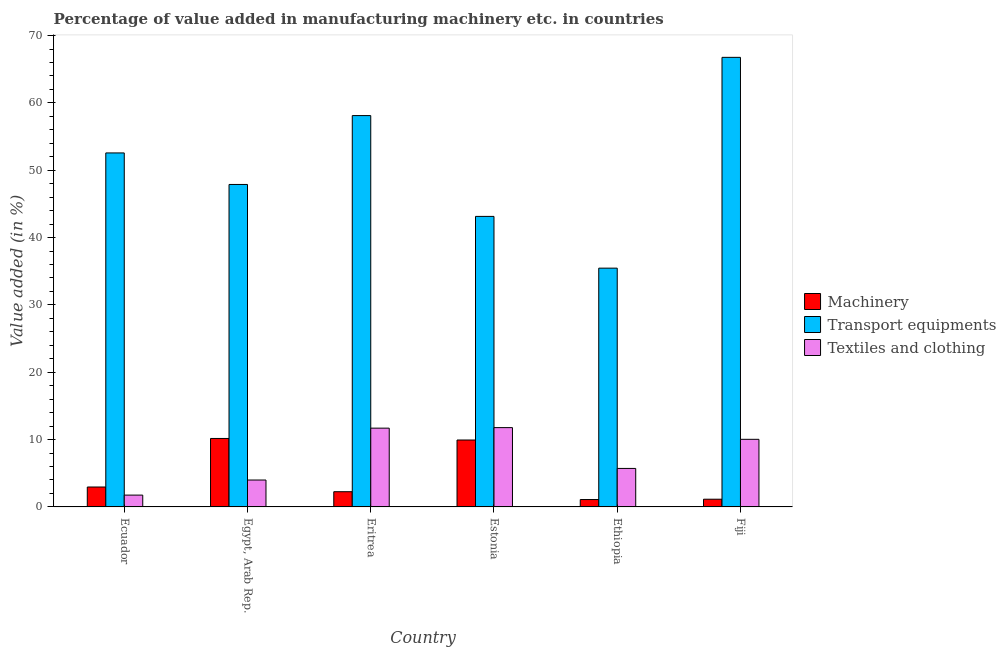How many different coloured bars are there?
Provide a succinct answer. 3. Are the number of bars on each tick of the X-axis equal?
Offer a very short reply. Yes. How many bars are there on the 5th tick from the left?
Provide a short and direct response. 3. How many bars are there on the 2nd tick from the right?
Offer a terse response. 3. What is the label of the 2nd group of bars from the left?
Your answer should be very brief. Egypt, Arab Rep. What is the value added in manufacturing transport equipments in Ethiopia?
Provide a succinct answer. 35.46. Across all countries, what is the maximum value added in manufacturing machinery?
Give a very brief answer. 10.17. Across all countries, what is the minimum value added in manufacturing textile and clothing?
Make the answer very short. 1.76. In which country was the value added in manufacturing machinery maximum?
Offer a very short reply. Egypt, Arab Rep. In which country was the value added in manufacturing machinery minimum?
Offer a very short reply. Ethiopia. What is the total value added in manufacturing machinery in the graph?
Give a very brief answer. 27.57. What is the difference between the value added in manufacturing transport equipments in Estonia and that in Fiji?
Offer a terse response. -23.62. What is the difference between the value added in manufacturing transport equipments in Fiji and the value added in manufacturing textile and clothing in Egypt, Arab Rep.?
Give a very brief answer. 62.77. What is the average value added in manufacturing transport equipments per country?
Offer a terse response. 50.66. What is the difference between the value added in manufacturing transport equipments and value added in manufacturing textile and clothing in Egypt, Arab Rep.?
Your response must be concise. 43.89. What is the ratio of the value added in manufacturing textile and clothing in Ecuador to that in Eritrea?
Offer a terse response. 0.15. What is the difference between the highest and the second highest value added in manufacturing machinery?
Offer a very short reply. 0.23. What is the difference between the highest and the lowest value added in manufacturing machinery?
Provide a succinct answer. 9.07. In how many countries, is the value added in manufacturing transport equipments greater than the average value added in manufacturing transport equipments taken over all countries?
Provide a succinct answer. 3. What does the 2nd bar from the left in Egypt, Arab Rep. represents?
Your response must be concise. Transport equipments. What does the 3rd bar from the right in Estonia represents?
Offer a terse response. Machinery. Is it the case that in every country, the sum of the value added in manufacturing machinery and value added in manufacturing transport equipments is greater than the value added in manufacturing textile and clothing?
Your response must be concise. Yes. Are all the bars in the graph horizontal?
Provide a short and direct response. No. What is the difference between two consecutive major ticks on the Y-axis?
Keep it short and to the point. 10. Are the values on the major ticks of Y-axis written in scientific E-notation?
Give a very brief answer. No. Does the graph contain any zero values?
Keep it short and to the point. No. How many legend labels are there?
Your answer should be very brief. 3. What is the title of the graph?
Provide a short and direct response. Percentage of value added in manufacturing machinery etc. in countries. What is the label or title of the Y-axis?
Ensure brevity in your answer.  Value added (in %). What is the Value added (in %) in Machinery in Ecuador?
Make the answer very short. 2.96. What is the Value added (in %) in Transport equipments in Ecuador?
Keep it short and to the point. 52.57. What is the Value added (in %) of Textiles and clothing in Ecuador?
Make the answer very short. 1.76. What is the Value added (in %) in Machinery in Egypt, Arab Rep.?
Keep it short and to the point. 10.17. What is the Value added (in %) in Transport equipments in Egypt, Arab Rep.?
Your answer should be compact. 47.89. What is the Value added (in %) of Textiles and clothing in Egypt, Arab Rep.?
Your answer should be very brief. 4. What is the Value added (in %) of Machinery in Eritrea?
Your answer should be compact. 2.26. What is the Value added (in %) in Transport equipments in Eritrea?
Offer a terse response. 58.12. What is the Value added (in %) in Textiles and clothing in Eritrea?
Keep it short and to the point. 11.7. What is the Value added (in %) in Machinery in Estonia?
Make the answer very short. 9.94. What is the Value added (in %) of Transport equipments in Estonia?
Provide a short and direct response. 43.15. What is the Value added (in %) of Textiles and clothing in Estonia?
Offer a terse response. 11.78. What is the Value added (in %) in Machinery in Ethiopia?
Ensure brevity in your answer.  1.1. What is the Value added (in %) of Transport equipments in Ethiopia?
Provide a succinct answer. 35.46. What is the Value added (in %) of Textiles and clothing in Ethiopia?
Offer a very short reply. 5.72. What is the Value added (in %) of Machinery in Fiji?
Give a very brief answer. 1.15. What is the Value added (in %) in Transport equipments in Fiji?
Offer a terse response. 66.77. What is the Value added (in %) in Textiles and clothing in Fiji?
Your response must be concise. 10.04. Across all countries, what is the maximum Value added (in %) of Machinery?
Offer a very short reply. 10.17. Across all countries, what is the maximum Value added (in %) of Transport equipments?
Your answer should be very brief. 66.77. Across all countries, what is the maximum Value added (in %) in Textiles and clothing?
Make the answer very short. 11.78. Across all countries, what is the minimum Value added (in %) of Machinery?
Your response must be concise. 1.1. Across all countries, what is the minimum Value added (in %) in Transport equipments?
Ensure brevity in your answer.  35.46. Across all countries, what is the minimum Value added (in %) of Textiles and clothing?
Your answer should be very brief. 1.76. What is the total Value added (in %) of Machinery in the graph?
Provide a succinct answer. 27.57. What is the total Value added (in %) of Transport equipments in the graph?
Your response must be concise. 303.96. What is the total Value added (in %) of Textiles and clothing in the graph?
Offer a very short reply. 44.99. What is the difference between the Value added (in %) of Machinery in Ecuador and that in Egypt, Arab Rep.?
Make the answer very short. -7.21. What is the difference between the Value added (in %) in Transport equipments in Ecuador and that in Egypt, Arab Rep.?
Your answer should be very brief. 4.68. What is the difference between the Value added (in %) of Textiles and clothing in Ecuador and that in Egypt, Arab Rep.?
Provide a succinct answer. -2.24. What is the difference between the Value added (in %) of Machinery in Ecuador and that in Eritrea?
Offer a terse response. 0.7. What is the difference between the Value added (in %) in Transport equipments in Ecuador and that in Eritrea?
Offer a very short reply. -5.55. What is the difference between the Value added (in %) in Textiles and clothing in Ecuador and that in Eritrea?
Provide a short and direct response. -9.94. What is the difference between the Value added (in %) of Machinery in Ecuador and that in Estonia?
Provide a succinct answer. -6.98. What is the difference between the Value added (in %) of Transport equipments in Ecuador and that in Estonia?
Offer a terse response. 9.43. What is the difference between the Value added (in %) of Textiles and clothing in Ecuador and that in Estonia?
Your response must be concise. -10.02. What is the difference between the Value added (in %) of Machinery in Ecuador and that in Ethiopia?
Provide a succinct answer. 1.86. What is the difference between the Value added (in %) of Transport equipments in Ecuador and that in Ethiopia?
Provide a succinct answer. 17.11. What is the difference between the Value added (in %) of Textiles and clothing in Ecuador and that in Ethiopia?
Provide a short and direct response. -3.96. What is the difference between the Value added (in %) of Machinery in Ecuador and that in Fiji?
Your response must be concise. 1.81. What is the difference between the Value added (in %) in Transport equipments in Ecuador and that in Fiji?
Provide a succinct answer. -14.19. What is the difference between the Value added (in %) in Textiles and clothing in Ecuador and that in Fiji?
Provide a succinct answer. -8.28. What is the difference between the Value added (in %) in Machinery in Egypt, Arab Rep. and that in Eritrea?
Your answer should be very brief. 7.91. What is the difference between the Value added (in %) in Transport equipments in Egypt, Arab Rep. and that in Eritrea?
Offer a very short reply. -10.23. What is the difference between the Value added (in %) in Textiles and clothing in Egypt, Arab Rep. and that in Eritrea?
Your answer should be compact. -7.7. What is the difference between the Value added (in %) of Machinery in Egypt, Arab Rep. and that in Estonia?
Offer a very short reply. 0.23. What is the difference between the Value added (in %) of Transport equipments in Egypt, Arab Rep. and that in Estonia?
Offer a very short reply. 4.74. What is the difference between the Value added (in %) of Textiles and clothing in Egypt, Arab Rep. and that in Estonia?
Your answer should be very brief. -7.78. What is the difference between the Value added (in %) of Machinery in Egypt, Arab Rep. and that in Ethiopia?
Keep it short and to the point. 9.07. What is the difference between the Value added (in %) in Transport equipments in Egypt, Arab Rep. and that in Ethiopia?
Your response must be concise. 12.43. What is the difference between the Value added (in %) of Textiles and clothing in Egypt, Arab Rep. and that in Ethiopia?
Your response must be concise. -1.72. What is the difference between the Value added (in %) in Machinery in Egypt, Arab Rep. and that in Fiji?
Keep it short and to the point. 9.02. What is the difference between the Value added (in %) of Transport equipments in Egypt, Arab Rep. and that in Fiji?
Offer a very short reply. -18.88. What is the difference between the Value added (in %) of Textiles and clothing in Egypt, Arab Rep. and that in Fiji?
Ensure brevity in your answer.  -6.04. What is the difference between the Value added (in %) in Machinery in Eritrea and that in Estonia?
Keep it short and to the point. -7.68. What is the difference between the Value added (in %) of Transport equipments in Eritrea and that in Estonia?
Offer a terse response. 14.97. What is the difference between the Value added (in %) in Textiles and clothing in Eritrea and that in Estonia?
Keep it short and to the point. -0.08. What is the difference between the Value added (in %) of Machinery in Eritrea and that in Ethiopia?
Offer a terse response. 1.16. What is the difference between the Value added (in %) in Transport equipments in Eritrea and that in Ethiopia?
Provide a succinct answer. 22.66. What is the difference between the Value added (in %) in Textiles and clothing in Eritrea and that in Ethiopia?
Your answer should be very brief. 5.98. What is the difference between the Value added (in %) of Machinery in Eritrea and that in Fiji?
Your response must be concise. 1.11. What is the difference between the Value added (in %) in Transport equipments in Eritrea and that in Fiji?
Offer a terse response. -8.65. What is the difference between the Value added (in %) in Textiles and clothing in Eritrea and that in Fiji?
Your response must be concise. 1.66. What is the difference between the Value added (in %) of Machinery in Estonia and that in Ethiopia?
Make the answer very short. 8.84. What is the difference between the Value added (in %) in Transport equipments in Estonia and that in Ethiopia?
Your answer should be compact. 7.68. What is the difference between the Value added (in %) of Textiles and clothing in Estonia and that in Ethiopia?
Provide a succinct answer. 6.06. What is the difference between the Value added (in %) of Machinery in Estonia and that in Fiji?
Your answer should be compact. 8.79. What is the difference between the Value added (in %) of Transport equipments in Estonia and that in Fiji?
Make the answer very short. -23.62. What is the difference between the Value added (in %) in Textiles and clothing in Estonia and that in Fiji?
Keep it short and to the point. 1.74. What is the difference between the Value added (in %) in Machinery in Ethiopia and that in Fiji?
Your answer should be compact. -0.05. What is the difference between the Value added (in %) of Transport equipments in Ethiopia and that in Fiji?
Provide a short and direct response. -31.31. What is the difference between the Value added (in %) in Textiles and clothing in Ethiopia and that in Fiji?
Ensure brevity in your answer.  -4.32. What is the difference between the Value added (in %) of Machinery in Ecuador and the Value added (in %) of Transport equipments in Egypt, Arab Rep.?
Your response must be concise. -44.93. What is the difference between the Value added (in %) of Machinery in Ecuador and the Value added (in %) of Textiles and clothing in Egypt, Arab Rep.?
Offer a terse response. -1.04. What is the difference between the Value added (in %) of Transport equipments in Ecuador and the Value added (in %) of Textiles and clothing in Egypt, Arab Rep.?
Your answer should be very brief. 48.58. What is the difference between the Value added (in %) in Machinery in Ecuador and the Value added (in %) in Transport equipments in Eritrea?
Offer a terse response. -55.16. What is the difference between the Value added (in %) of Machinery in Ecuador and the Value added (in %) of Textiles and clothing in Eritrea?
Offer a terse response. -8.74. What is the difference between the Value added (in %) in Transport equipments in Ecuador and the Value added (in %) in Textiles and clothing in Eritrea?
Offer a very short reply. 40.87. What is the difference between the Value added (in %) in Machinery in Ecuador and the Value added (in %) in Transport equipments in Estonia?
Keep it short and to the point. -40.19. What is the difference between the Value added (in %) of Machinery in Ecuador and the Value added (in %) of Textiles and clothing in Estonia?
Offer a terse response. -8.82. What is the difference between the Value added (in %) in Transport equipments in Ecuador and the Value added (in %) in Textiles and clothing in Estonia?
Your response must be concise. 40.79. What is the difference between the Value added (in %) in Machinery in Ecuador and the Value added (in %) in Transport equipments in Ethiopia?
Your answer should be compact. -32.5. What is the difference between the Value added (in %) of Machinery in Ecuador and the Value added (in %) of Textiles and clothing in Ethiopia?
Offer a very short reply. -2.76. What is the difference between the Value added (in %) in Transport equipments in Ecuador and the Value added (in %) in Textiles and clothing in Ethiopia?
Offer a terse response. 46.86. What is the difference between the Value added (in %) in Machinery in Ecuador and the Value added (in %) in Transport equipments in Fiji?
Ensure brevity in your answer.  -63.81. What is the difference between the Value added (in %) of Machinery in Ecuador and the Value added (in %) of Textiles and clothing in Fiji?
Give a very brief answer. -7.08. What is the difference between the Value added (in %) of Transport equipments in Ecuador and the Value added (in %) of Textiles and clothing in Fiji?
Your response must be concise. 42.53. What is the difference between the Value added (in %) in Machinery in Egypt, Arab Rep. and the Value added (in %) in Transport equipments in Eritrea?
Provide a short and direct response. -47.95. What is the difference between the Value added (in %) in Machinery in Egypt, Arab Rep. and the Value added (in %) in Textiles and clothing in Eritrea?
Provide a succinct answer. -1.53. What is the difference between the Value added (in %) in Transport equipments in Egypt, Arab Rep. and the Value added (in %) in Textiles and clothing in Eritrea?
Offer a very short reply. 36.19. What is the difference between the Value added (in %) of Machinery in Egypt, Arab Rep. and the Value added (in %) of Transport equipments in Estonia?
Provide a short and direct response. -32.98. What is the difference between the Value added (in %) of Machinery in Egypt, Arab Rep. and the Value added (in %) of Textiles and clothing in Estonia?
Your answer should be compact. -1.61. What is the difference between the Value added (in %) in Transport equipments in Egypt, Arab Rep. and the Value added (in %) in Textiles and clothing in Estonia?
Provide a short and direct response. 36.11. What is the difference between the Value added (in %) in Machinery in Egypt, Arab Rep. and the Value added (in %) in Transport equipments in Ethiopia?
Offer a very short reply. -25.29. What is the difference between the Value added (in %) in Machinery in Egypt, Arab Rep. and the Value added (in %) in Textiles and clothing in Ethiopia?
Your response must be concise. 4.45. What is the difference between the Value added (in %) of Transport equipments in Egypt, Arab Rep. and the Value added (in %) of Textiles and clothing in Ethiopia?
Your answer should be compact. 42.17. What is the difference between the Value added (in %) in Machinery in Egypt, Arab Rep. and the Value added (in %) in Transport equipments in Fiji?
Keep it short and to the point. -56.6. What is the difference between the Value added (in %) of Machinery in Egypt, Arab Rep. and the Value added (in %) of Textiles and clothing in Fiji?
Ensure brevity in your answer.  0.13. What is the difference between the Value added (in %) of Transport equipments in Egypt, Arab Rep. and the Value added (in %) of Textiles and clothing in Fiji?
Your answer should be very brief. 37.85. What is the difference between the Value added (in %) in Machinery in Eritrea and the Value added (in %) in Transport equipments in Estonia?
Provide a succinct answer. -40.89. What is the difference between the Value added (in %) of Machinery in Eritrea and the Value added (in %) of Textiles and clothing in Estonia?
Provide a short and direct response. -9.52. What is the difference between the Value added (in %) of Transport equipments in Eritrea and the Value added (in %) of Textiles and clothing in Estonia?
Your answer should be compact. 46.34. What is the difference between the Value added (in %) of Machinery in Eritrea and the Value added (in %) of Transport equipments in Ethiopia?
Give a very brief answer. -33.2. What is the difference between the Value added (in %) in Machinery in Eritrea and the Value added (in %) in Textiles and clothing in Ethiopia?
Ensure brevity in your answer.  -3.46. What is the difference between the Value added (in %) of Transport equipments in Eritrea and the Value added (in %) of Textiles and clothing in Ethiopia?
Ensure brevity in your answer.  52.4. What is the difference between the Value added (in %) in Machinery in Eritrea and the Value added (in %) in Transport equipments in Fiji?
Provide a short and direct response. -64.51. What is the difference between the Value added (in %) of Machinery in Eritrea and the Value added (in %) of Textiles and clothing in Fiji?
Give a very brief answer. -7.78. What is the difference between the Value added (in %) in Transport equipments in Eritrea and the Value added (in %) in Textiles and clothing in Fiji?
Provide a succinct answer. 48.08. What is the difference between the Value added (in %) in Machinery in Estonia and the Value added (in %) in Transport equipments in Ethiopia?
Give a very brief answer. -25.52. What is the difference between the Value added (in %) in Machinery in Estonia and the Value added (in %) in Textiles and clothing in Ethiopia?
Your answer should be very brief. 4.22. What is the difference between the Value added (in %) in Transport equipments in Estonia and the Value added (in %) in Textiles and clothing in Ethiopia?
Your answer should be compact. 37.43. What is the difference between the Value added (in %) of Machinery in Estonia and the Value added (in %) of Transport equipments in Fiji?
Provide a succinct answer. -56.83. What is the difference between the Value added (in %) in Machinery in Estonia and the Value added (in %) in Textiles and clothing in Fiji?
Offer a terse response. -0.1. What is the difference between the Value added (in %) of Transport equipments in Estonia and the Value added (in %) of Textiles and clothing in Fiji?
Ensure brevity in your answer.  33.11. What is the difference between the Value added (in %) of Machinery in Ethiopia and the Value added (in %) of Transport equipments in Fiji?
Provide a short and direct response. -65.67. What is the difference between the Value added (in %) of Machinery in Ethiopia and the Value added (in %) of Textiles and clothing in Fiji?
Your response must be concise. -8.94. What is the difference between the Value added (in %) in Transport equipments in Ethiopia and the Value added (in %) in Textiles and clothing in Fiji?
Your response must be concise. 25.42. What is the average Value added (in %) in Machinery per country?
Keep it short and to the point. 4.6. What is the average Value added (in %) of Transport equipments per country?
Your answer should be compact. 50.66. What is the average Value added (in %) of Textiles and clothing per country?
Provide a short and direct response. 7.5. What is the difference between the Value added (in %) of Machinery and Value added (in %) of Transport equipments in Ecuador?
Ensure brevity in your answer.  -49.61. What is the difference between the Value added (in %) in Machinery and Value added (in %) in Textiles and clothing in Ecuador?
Make the answer very short. 1.2. What is the difference between the Value added (in %) in Transport equipments and Value added (in %) in Textiles and clothing in Ecuador?
Provide a short and direct response. 50.82. What is the difference between the Value added (in %) of Machinery and Value added (in %) of Transport equipments in Egypt, Arab Rep.?
Make the answer very short. -37.72. What is the difference between the Value added (in %) of Machinery and Value added (in %) of Textiles and clothing in Egypt, Arab Rep.?
Keep it short and to the point. 6.17. What is the difference between the Value added (in %) of Transport equipments and Value added (in %) of Textiles and clothing in Egypt, Arab Rep.?
Keep it short and to the point. 43.89. What is the difference between the Value added (in %) in Machinery and Value added (in %) in Transport equipments in Eritrea?
Your response must be concise. -55.86. What is the difference between the Value added (in %) in Machinery and Value added (in %) in Textiles and clothing in Eritrea?
Your answer should be very brief. -9.44. What is the difference between the Value added (in %) in Transport equipments and Value added (in %) in Textiles and clothing in Eritrea?
Keep it short and to the point. 46.42. What is the difference between the Value added (in %) of Machinery and Value added (in %) of Transport equipments in Estonia?
Provide a short and direct response. -33.21. What is the difference between the Value added (in %) in Machinery and Value added (in %) in Textiles and clothing in Estonia?
Provide a succinct answer. -1.84. What is the difference between the Value added (in %) in Transport equipments and Value added (in %) in Textiles and clothing in Estonia?
Offer a very short reply. 31.37. What is the difference between the Value added (in %) of Machinery and Value added (in %) of Transport equipments in Ethiopia?
Provide a short and direct response. -34.36. What is the difference between the Value added (in %) in Machinery and Value added (in %) in Textiles and clothing in Ethiopia?
Make the answer very short. -4.62. What is the difference between the Value added (in %) in Transport equipments and Value added (in %) in Textiles and clothing in Ethiopia?
Keep it short and to the point. 29.75. What is the difference between the Value added (in %) in Machinery and Value added (in %) in Transport equipments in Fiji?
Provide a short and direct response. -65.62. What is the difference between the Value added (in %) of Machinery and Value added (in %) of Textiles and clothing in Fiji?
Keep it short and to the point. -8.89. What is the difference between the Value added (in %) in Transport equipments and Value added (in %) in Textiles and clothing in Fiji?
Offer a terse response. 56.73. What is the ratio of the Value added (in %) of Machinery in Ecuador to that in Egypt, Arab Rep.?
Your answer should be very brief. 0.29. What is the ratio of the Value added (in %) in Transport equipments in Ecuador to that in Egypt, Arab Rep.?
Keep it short and to the point. 1.1. What is the ratio of the Value added (in %) in Textiles and clothing in Ecuador to that in Egypt, Arab Rep.?
Offer a very short reply. 0.44. What is the ratio of the Value added (in %) of Machinery in Ecuador to that in Eritrea?
Keep it short and to the point. 1.31. What is the ratio of the Value added (in %) of Transport equipments in Ecuador to that in Eritrea?
Offer a very short reply. 0.9. What is the ratio of the Value added (in %) of Textiles and clothing in Ecuador to that in Eritrea?
Ensure brevity in your answer.  0.15. What is the ratio of the Value added (in %) of Machinery in Ecuador to that in Estonia?
Offer a very short reply. 0.3. What is the ratio of the Value added (in %) in Transport equipments in Ecuador to that in Estonia?
Your response must be concise. 1.22. What is the ratio of the Value added (in %) in Textiles and clothing in Ecuador to that in Estonia?
Ensure brevity in your answer.  0.15. What is the ratio of the Value added (in %) in Machinery in Ecuador to that in Ethiopia?
Your answer should be very brief. 2.69. What is the ratio of the Value added (in %) of Transport equipments in Ecuador to that in Ethiopia?
Offer a very short reply. 1.48. What is the ratio of the Value added (in %) of Textiles and clothing in Ecuador to that in Ethiopia?
Your answer should be compact. 0.31. What is the ratio of the Value added (in %) in Machinery in Ecuador to that in Fiji?
Your answer should be very brief. 2.58. What is the ratio of the Value added (in %) in Transport equipments in Ecuador to that in Fiji?
Your answer should be very brief. 0.79. What is the ratio of the Value added (in %) in Textiles and clothing in Ecuador to that in Fiji?
Your answer should be compact. 0.17. What is the ratio of the Value added (in %) of Machinery in Egypt, Arab Rep. to that in Eritrea?
Offer a very short reply. 4.5. What is the ratio of the Value added (in %) in Transport equipments in Egypt, Arab Rep. to that in Eritrea?
Ensure brevity in your answer.  0.82. What is the ratio of the Value added (in %) of Textiles and clothing in Egypt, Arab Rep. to that in Eritrea?
Provide a succinct answer. 0.34. What is the ratio of the Value added (in %) in Machinery in Egypt, Arab Rep. to that in Estonia?
Keep it short and to the point. 1.02. What is the ratio of the Value added (in %) in Transport equipments in Egypt, Arab Rep. to that in Estonia?
Make the answer very short. 1.11. What is the ratio of the Value added (in %) of Textiles and clothing in Egypt, Arab Rep. to that in Estonia?
Give a very brief answer. 0.34. What is the ratio of the Value added (in %) in Machinery in Egypt, Arab Rep. to that in Ethiopia?
Offer a very short reply. 9.26. What is the ratio of the Value added (in %) of Transport equipments in Egypt, Arab Rep. to that in Ethiopia?
Make the answer very short. 1.35. What is the ratio of the Value added (in %) in Textiles and clothing in Egypt, Arab Rep. to that in Ethiopia?
Provide a short and direct response. 0.7. What is the ratio of the Value added (in %) of Machinery in Egypt, Arab Rep. to that in Fiji?
Your answer should be compact. 8.87. What is the ratio of the Value added (in %) of Transport equipments in Egypt, Arab Rep. to that in Fiji?
Give a very brief answer. 0.72. What is the ratio of the Value added (in %) of Textiles and clothing in Egypt, Arab Rep. to that in Fiji?
Offer a terse response. 0.4. What is the ratio of the Value added (in %) in Machinery in Eritrea to that in Estonia?
Your answer should be very brief. 0.23. What is the ratio of the Value added (in %) in Transport equipments in Eritrea to that in Estonia?
Your response must be concise. 1.35. What is the ratio of the Value added (in %) of Machinery in Eritrea to that in Ethiopia?
Offer a terse response. 2.06. What is the ratio of the Value added (in %) of Transport equipments in Eritrea to that in Ethiopia?
Provide a succinct answer. 1.64. What is the ratio of the Value added (in %) in Textiles and clothing in Eritrea to that in Ethiopia?
Your answer should be compact. 2.05. What is the ratio of the Value added (in %) in Machinery in Eritrea to that in Fiji?
Give a very brief answer. 1.97. What is the ratio of the Value added (in %) of Transport equipments in Eritrea to that in Fiji?
Ensure brevity in your answer.  0.87. What is the ratio of the Value added (in %) in Textiles and clothing in Eritrea to that in Fiji?
Give a very brief answer. 1.17. What is the ratio of the Value added (in %) of Machinery in Estonia to that in Ethiopia?
Ensure brevity in your answer.  9.05. What is the ratio of the Value added (in %) of Transport equipments in Estonia to that in Ethiopia?
Offer a very short reply. 1.22. What is the ratio of the Value added (in %) in Textiles and clothing in Estonia to that in Ethiopia?
Your answer should be very brief. 2.06. What is the ratio of the Value added (in %) in Machinery in Estonia to that in Fiji?
Keep it short and to the point. 8.67. What is the ratio of the Value added (in %) of Transport equipments in Estonia to that in Fiji?
Make the answer very short. 0.65. What is the ratio of the Value added (in %) of Textiles and clothing in Estonia to that in Fiji?
Your answer should be very brief. 1.17. What is the ratio of the Value added (in %) of Machinery in Ethiopia to that in Fiji?
Your answer should be compact. 0.96. What is the ratio of the Value added (in %) in Transport equipments in Ethiopia to that in Fiji?
Make the answer very short. 0.53. What is the ratio of the Value added (in %) of Textiles and clothing in Ethiopia to that in Fiji?
Your answer should be compact. 0.57. What is the difference between the highest and the second highest Value added (in %) in Machinery?
Give a very brief answer. 0.23. What is the difference between the highest and the second highest Value added (in %) in Transport equipments?
Your answer should be very brief. 8.65. What is the difference between the highest and the second highest Value added (in %) of Textiles and clothing?
Your answer should be very brief. 0.08. What is the difference between the highest and the lowest Value added (in %) of Machinery?
Your answer should be compact. 9.07. What is the difference between the highest and the lowest Value added (in %) of Transport equipments?
Your response must be concise. 31.31. What is the difference between the highest and the lowest Value added (in %) of Textiles and clothing?
Your response must be concise. 10.02. 